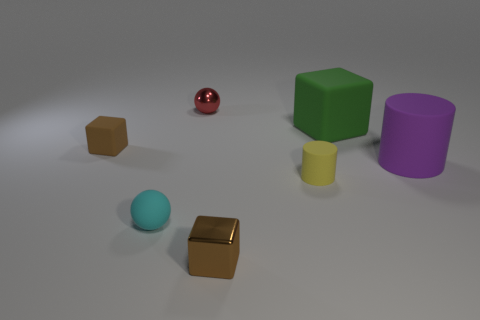What is the size of the matte block that is the same color as the tiny metal block?
Your answer should be compact. Small. There is another small block that is the same color as the tiny matte cube; what is it made of?
Your answer should be very brief. Metal. There is a shiny object behind the small brown thing that is left of the small brown metallic block; what shape is it?
Provide a short and direct response. Sphere. Are there fewer red things than brown things?
Your response must be concise. Yes. Is the size of the purple matte object the same as the rubber cube to the right of the small brown rubber object?
Your response must be concise. Yes. What color is the cube that is left of the metallic thing in front of the tiny yellow cylinder?
Your answer should be compact. Brown. What number of objects are either rubber objects that are in front of the brown rubber object or matte cubes that are on the left side of the small cyan rubber object?
Your answer should be compact. 4. Do the brown matte cube and the cyan matte thing have the same size?
Offer a very short reply. Yes. Does the small brown thing behind the big purple rubber thing have the same shape as the shiny object in front of the big green matte cube?
Offer a very short reply. Yes. What size is the green matte object?
Offer a very short reply. Large. 